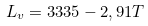Convert formula to latex. <formula><loc_0><loc_0><loc_500><loc_500>L _ { v } = 3 3 3 5 - 2 , 9 1 T</formula> 